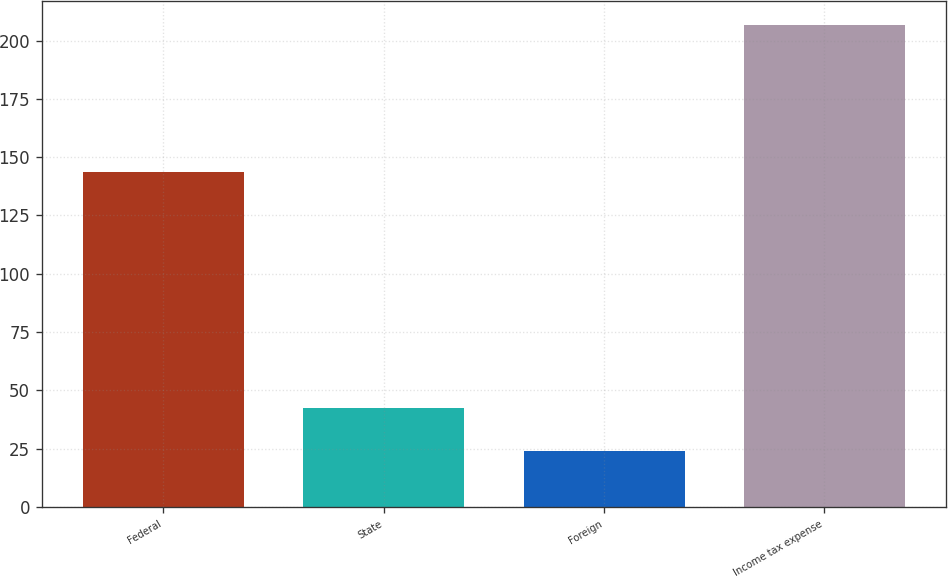<chart> <loc_0><loc_0><loc_500><loc_500><bar_chart><fcel>Federal<fcel>State<fcel>Foreign<fcel>Income tax expense<nl><fcel>143.8<fcel>42.36<fcel>24.1<fcel>206.7<nl></chart> 